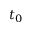Convert formula to latex. <formula><loc_0><loc_0><loc_500><loc_500>t _ { 0 }</formula> 